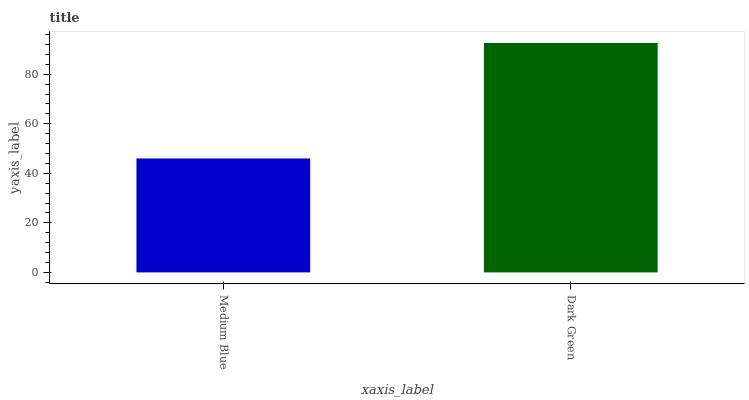Is Medium Blue the minimum?
Answer yes or no. Yes. Is Dark Green the maximum?
Answer yes or no. Yes. Is Dark Green the minimum?
Answer yes or no. No. Is Dark Green greater than Medium Blue?
Answer yes or no. Yes. Is Medium Blue less than Dark Green?
Answer yes or no. Yes. Is Medium Blue greater than Dark Green?
Answer yes or no. No. Is Dark Green less than Medium Blue?
Answer yes or no. No. Is Dark Green the high median?
Answer yes or no. Yes. Is Medium Blue the low median?
Answer yes or no. Yes. Is Medium Blue the high median?
Answer yes or no. No. Is Dark Green the low median?
Answer yes or no. No. 